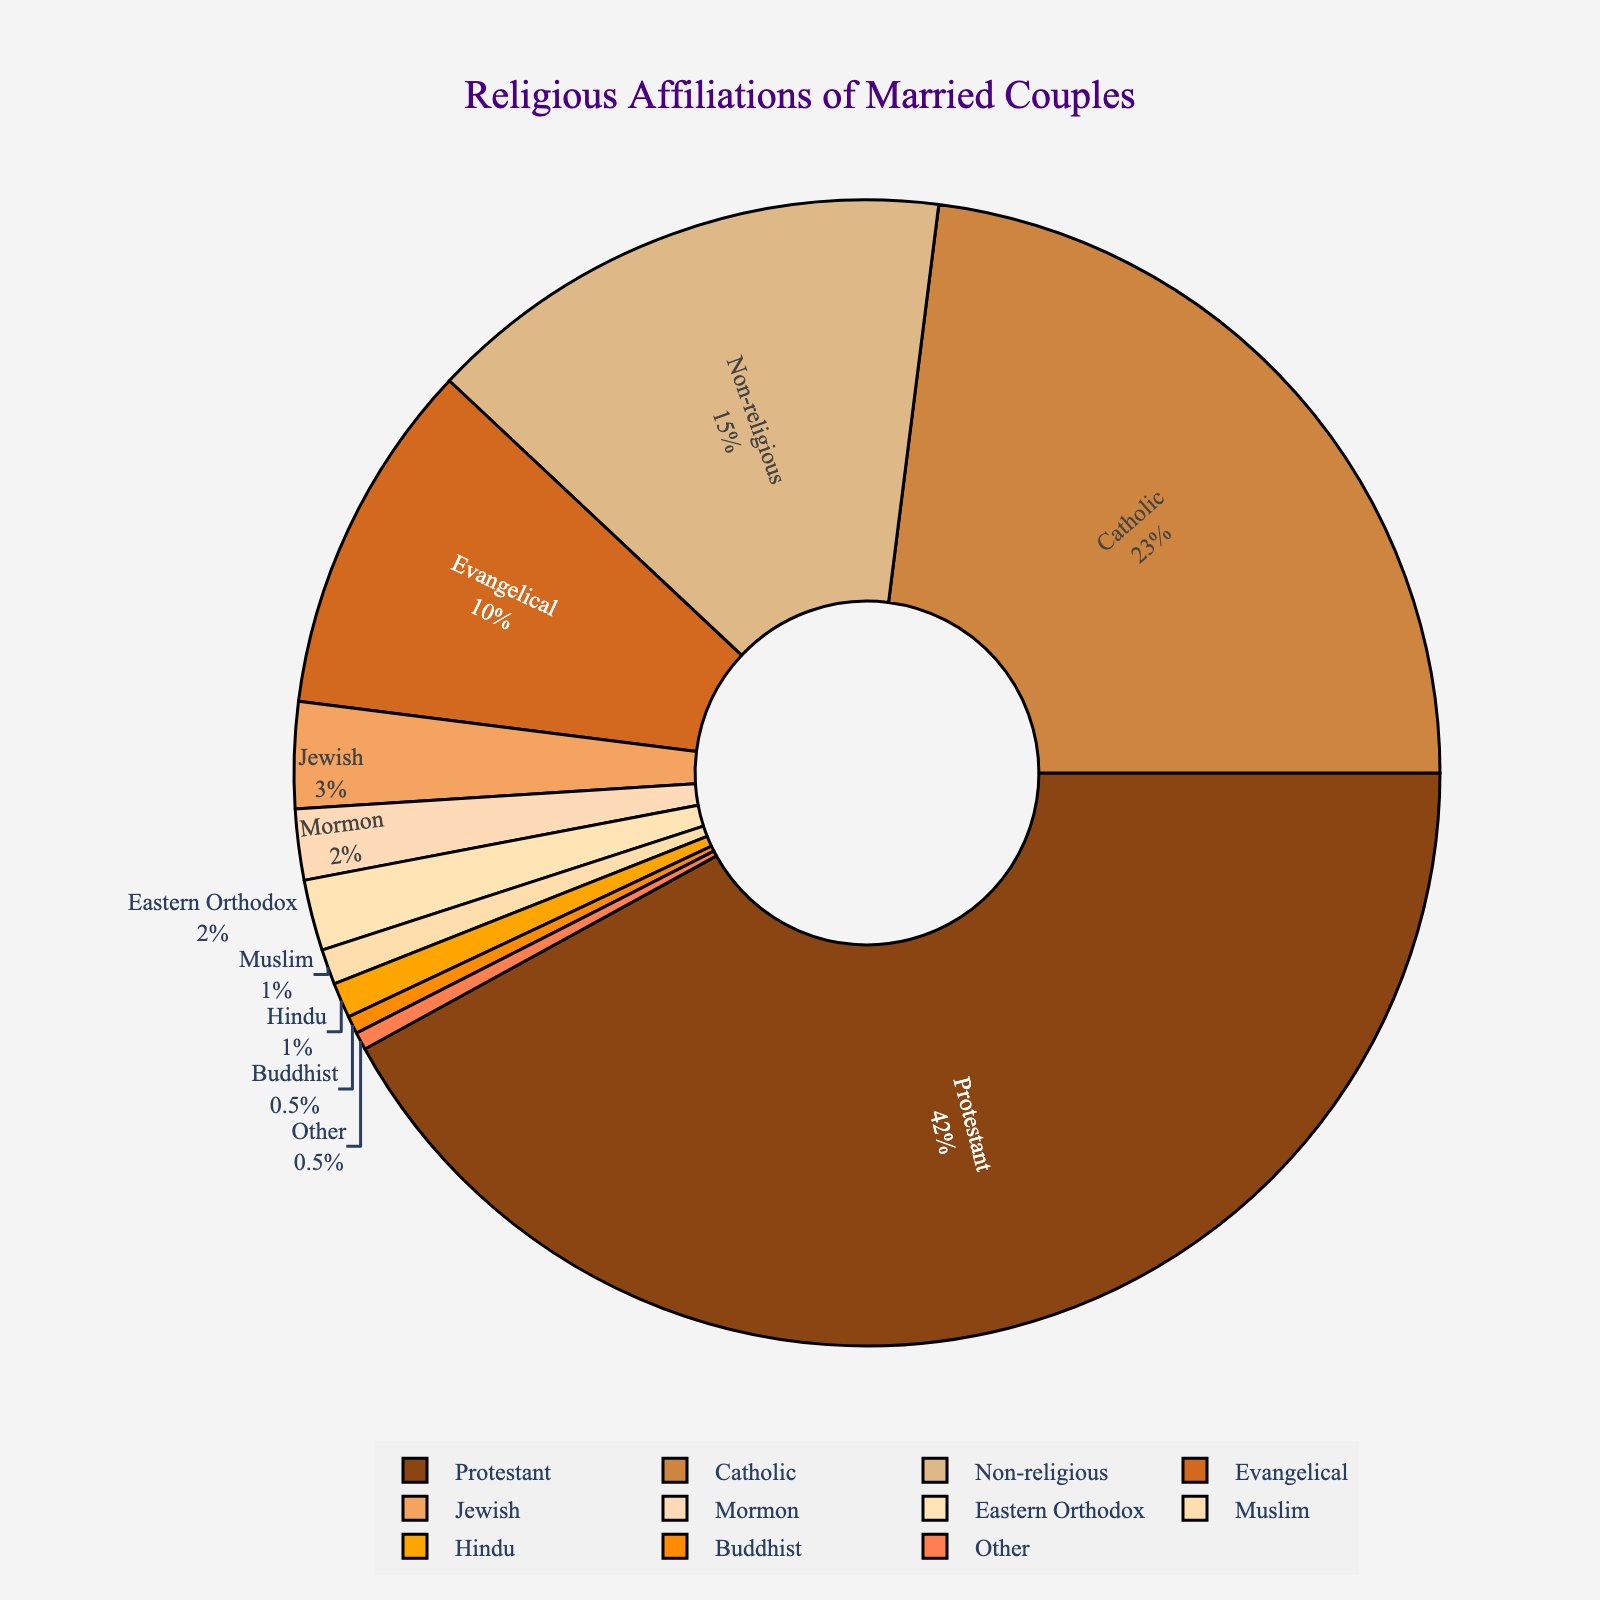What is the most common religious affiliation among married couples? From the pie chart, the largest segment represents the Protestant affiliation with a significant percentage of 42%.
Answer: Protestant What is the combined percentage of married couples who are either Catholic or Non-religious? The percentage of Catholic affiliation is 23%, and for Non-religious, it's 15%. Adding these together gives 23% + 15% = 38%.
Answer: 38% Which religious affiliations have a percentage less than 5%? By looking at the pie chart segments, the affiliations with less than 5% are Jewish (3%), Mormon (2%), Eastern Orthodox (2%), Muslim (1%), Hindu (1%), Buddhist (0.5%), and Other (0.5%).
Answer: Jewish, Mormon, Eastern Orthodox, Muslim, Hindu, Buddhist, Other How much larger is the percentage of Protestants compared to Evangelicals? Protestants have 42% while Evangelicals have 10%. The difference is calculated as 42% - 10% = 32%.
Answer: 32% What is the color of the segment representing the Catholic affiliation? Observing the colors in the pie chart, the Catholic segment is depicted with a specific brownish color.
Answer: A brownish color Estimate the total percentage of married couples who belong to religious affiliations categorized together as "Other." The 'Other' category directly labeled on the pie chart has a percentage of 0.5%.
Answer: 0.5% How does the percentage of Non-religious couples compare to that of Jewish and Muslim couples combined? Non-religious couples make up 15%. For Jewish (3%) and Muslim (1%) combined, the sum is 3% + 1% = 4%. Therefore, Non-religious couples have 15% - 4% = 11% more.
Answer: 11% more What is the total percentage of married couples who are either Buddhist or Hindu? The percentage for Buddhist is 0.5% and for Hindu is 1%. Adding these gives 0.5% + 1% = 1.5%.
Answer: 1.5% Among smaller segments, which has the same percentage as "Other"? Observing the smaller segments, "Buddhist" also has a percentage of 0.5%, which is the same as "Other".
Answer: Buddhist 